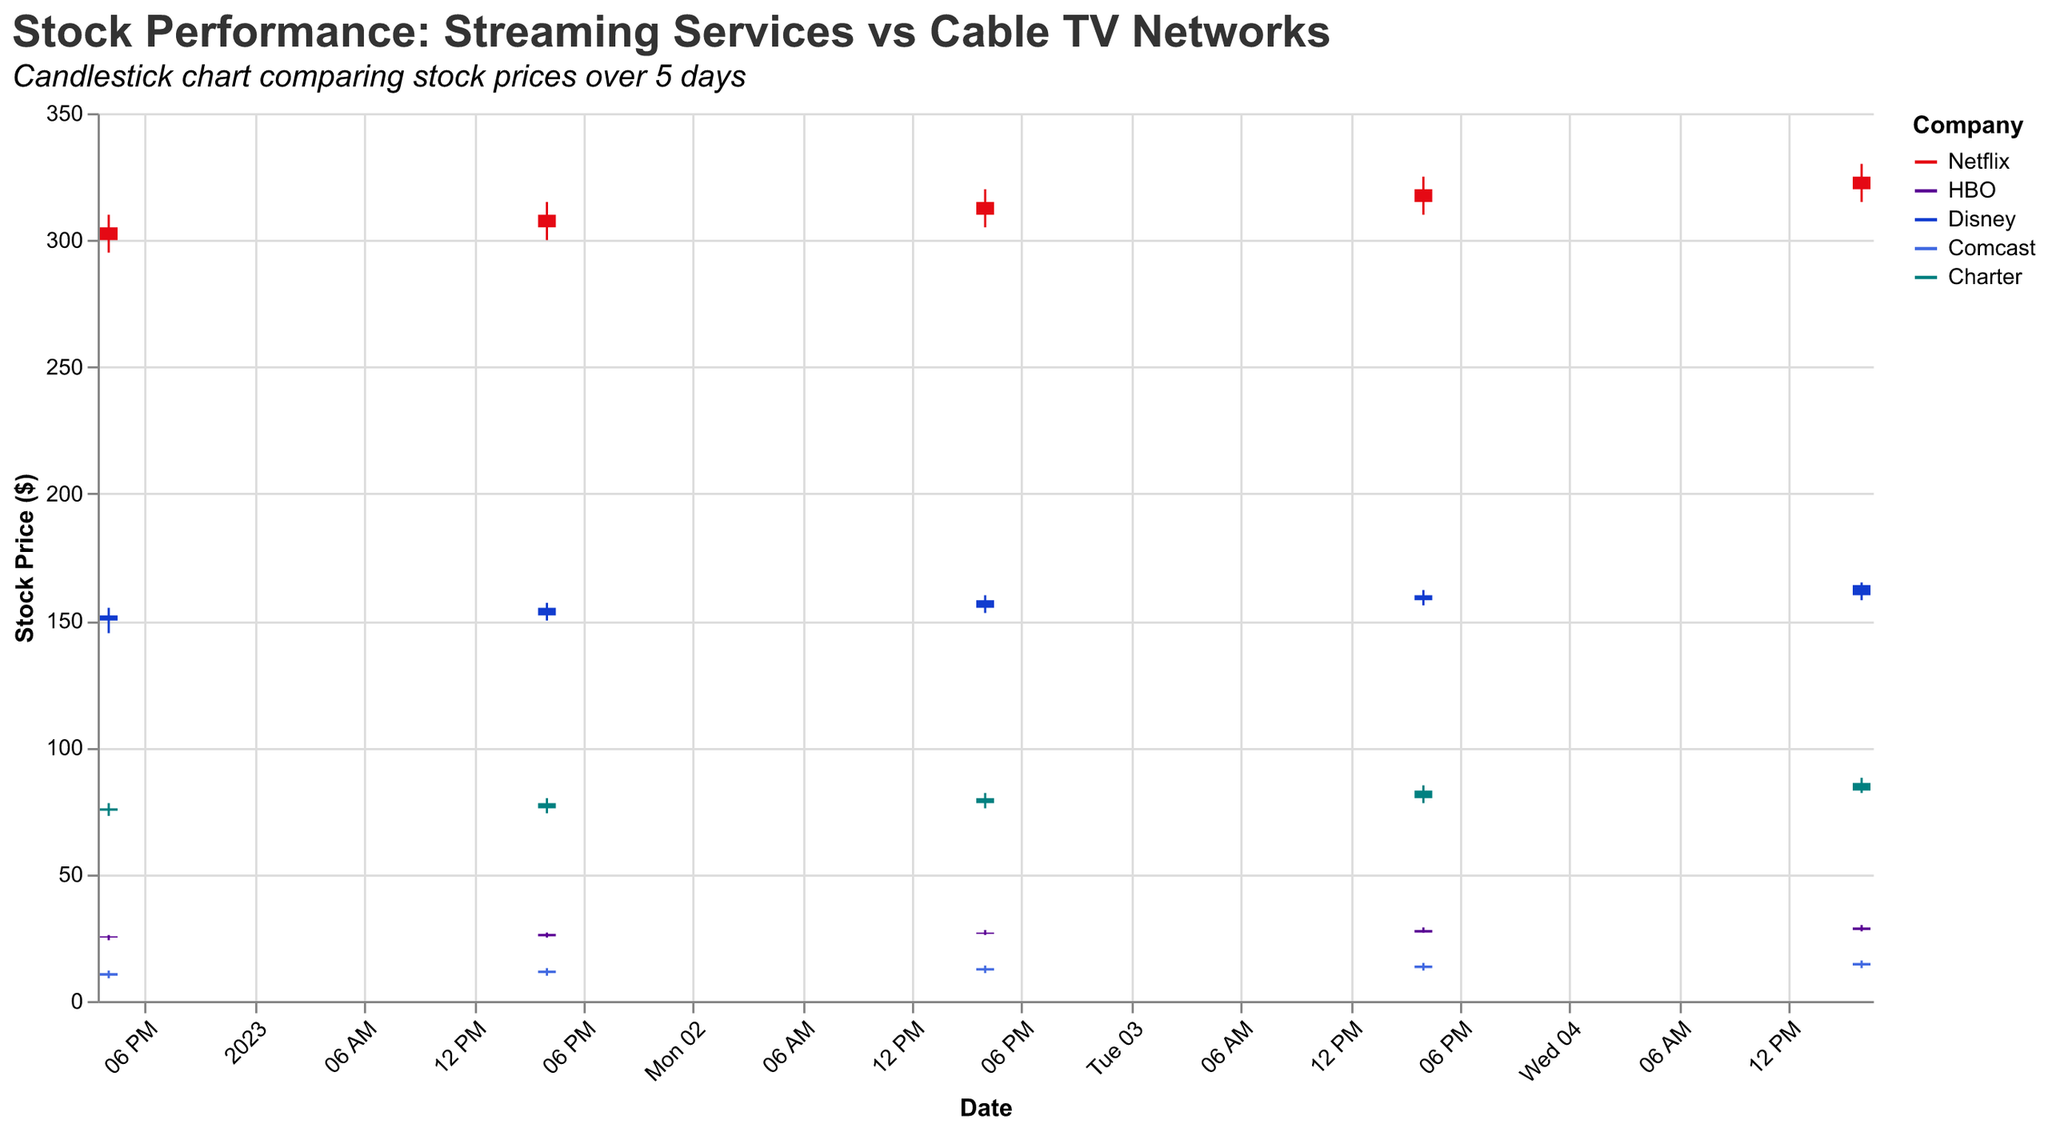how many companies are represented in the figure? The figure legend and color coding indicate five companies: Netflix, HBO, Disney, Comcast, and Charter.
Answer: 5 what is the title of the chart? The title is displayed at the top of the chart. It reads "Stock Performance: Streaming Services vs Cable TV Networks".
Answer: Stock Performance: Streaming Services vs Cable TV Networks what is the closing stock price for Netflix on January 3, 2023? Look for the specific entry in the data for Netflix on January 3, 2023. The "Close" value is 315.
Answer: 315 which company showed the highest closing price on January 5, 2023? Among the closing prices on January 5, 2023, Netflix has the highest closing price of 325.
Answer: Netflix how did HBO's stock price change from January 1 to January 5, 2023? HBO’s stock opened at 25 on January 1 and closed at 29 on January 5. The change is calculated as 29 - 25.
Answer: Increased by 4 which company had the highest trading volume on January 1, 2023? Look for the volume values on January 1, 2023, across all companies. Disney had the highest volume with 7,000,000 shares traded.
Answer: Disney compare the stock price range for Comcast on January 4, 2023, with its range on January 5, 2023. Compute the range (High - Low) for January 4 and January 5 for Comcast. January 4: 15 - 12 = 3; January 5: 16 - 13 = 3.
Answer: Both days have a range of 3 which company had the widest stock price range on January 2, 2023? Compare the ranges for each company on January 2. The range is High - Low. HBO has the widest range from 27 - 25 = 2.
Answer: HBO what was the average closing price for Disney from January 1 to January 5, 2023? The closing prices for Disney are 152, 155, 158, 160, and 164. Average = (152 + 155 + 158 + 160 + 164) / 5. Calculation: 789 / 5 = 157.8
Answer: 157.8 compare the opening and closing prices for Charter on January 4, 2023. Check the "Open" and "Close" values for Charter on January 4, 2023. Open = 80, Close = 83.  Difference = 83 - 80 = 3
Answer: Increased by 3 what is the highest stock price observed across all companies and days? Look through the "High" values for all entries to determine the maximum. The highest High value is 330 for Netflix on January 5.
Answer: 330 